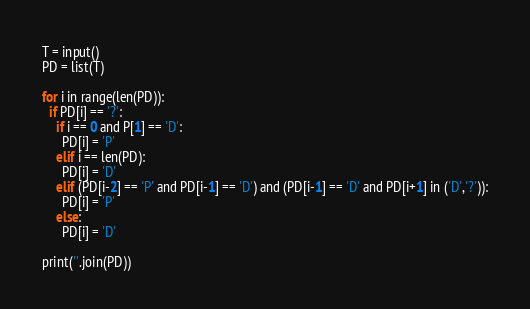<code> <loc_0><loc_0><loc_500><loc_500><_Python_>T = input()
PD = list(T)

for i in range(len(PD)):
  if PD[i] == '?':
    if i == 0 and P[1] == 'D':
      PD[i] = 'P'
    elif i == len(PD):
      PD[i] = 'D'
    elif (PD[i-2] == 'P' and PD[i-1] == 'D') and (PD[i-1] == 'D' and PD[i+1] in ('D','?')):
      PD[i] = 'P'
    else:
      PD[i] = 'D'
      
print(''.join(PD))</code> 